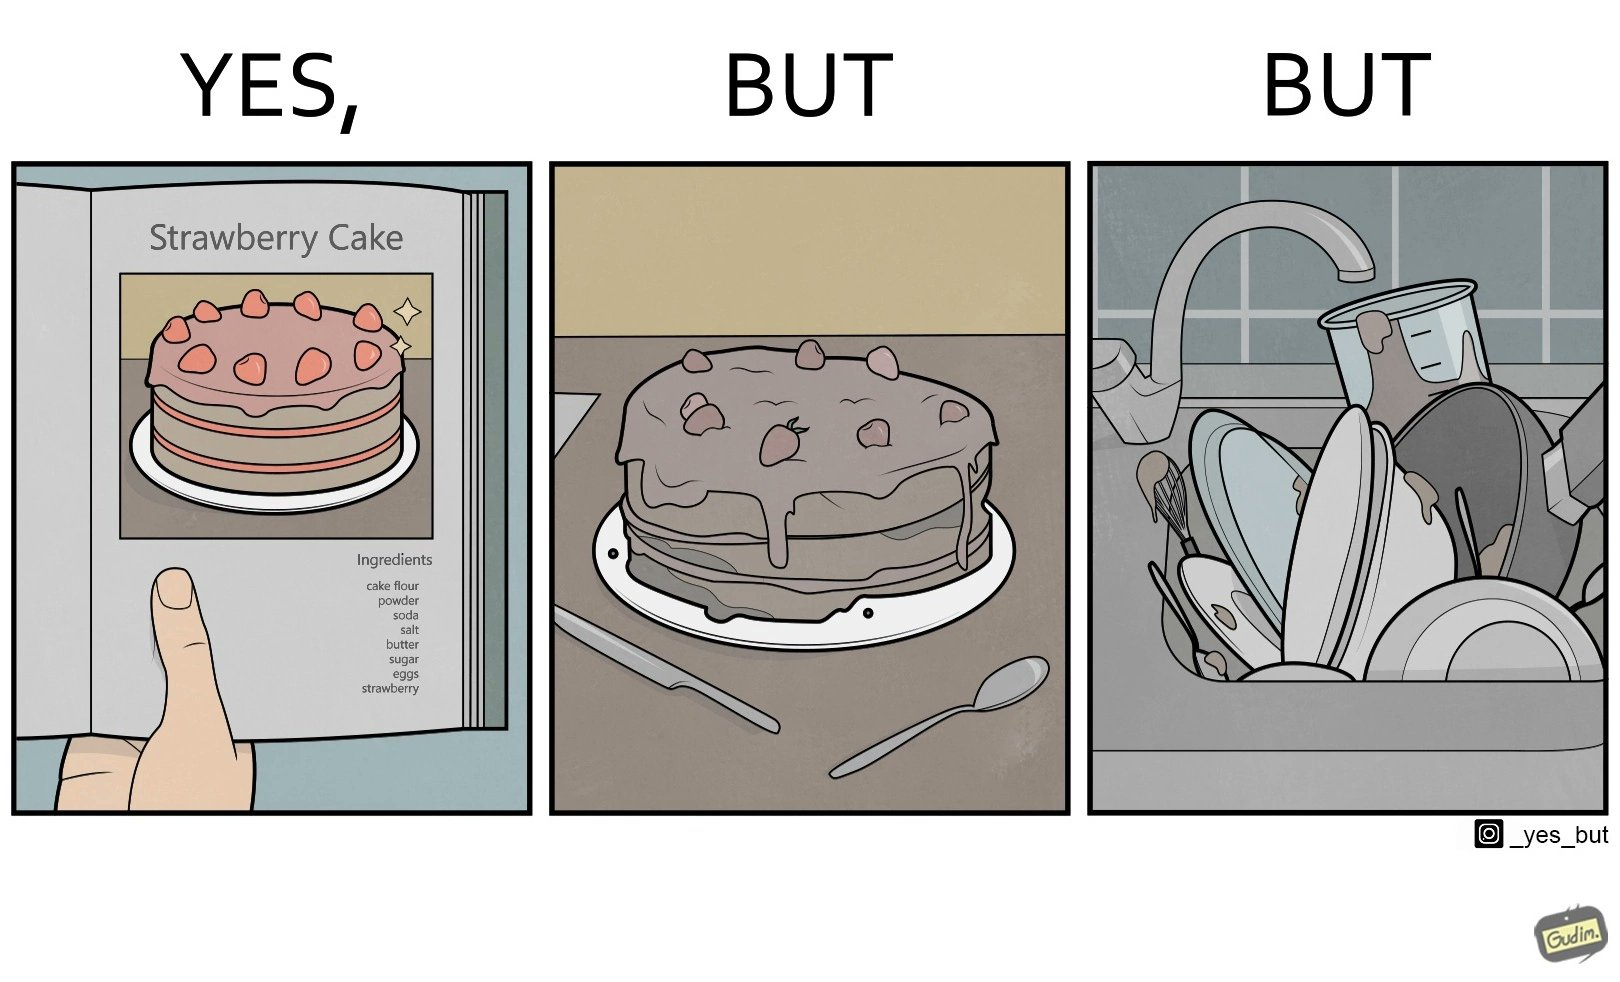What do you see in each half of this image? In the left part of the image: a page of a book showing the image of a strawberry cake, along with its ingredients. In the right part of the image: a cake on a plate, along with a bunch of used utensils to be washed. 